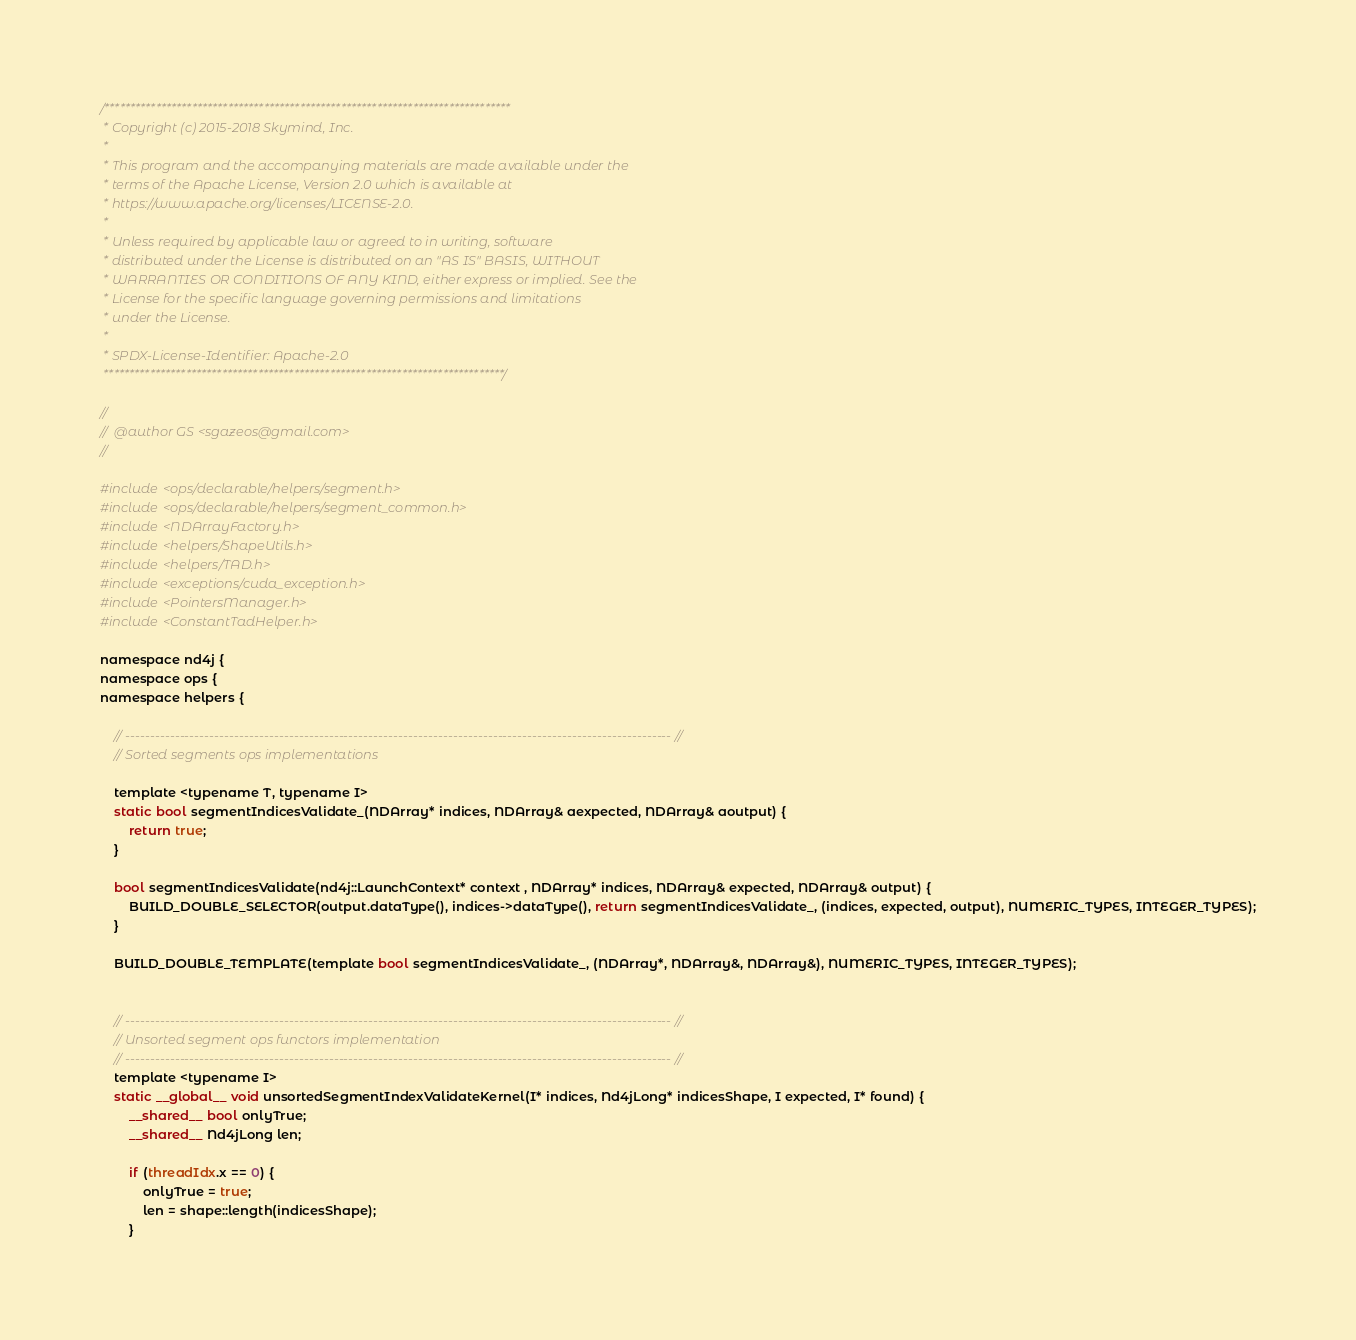Convert code to text. <code><loc_0><loc_0><loc_500><loc_500><_Cuda_>/*******************************************************************************
 * Copyright (c) 2015-2018 Skymind, Inc.
 *
 * This program and the accompanying materials are made available under the
 * terms of the Apache License, Version 2.0 which is available at
 * https://www.apache.org/licenses/LICENSE-2.0.
 *
 * Unless required by applicable law or agreed to in writing, software
 * distributed under the License is distributed on an "AS IS" BASIS, WITHOUT
 * WARRANTIES OR CONDITIONS OF ANY KIND, either express or implied. See the
 * License for the specific language governing permissions and limitations
 * under the License.
 *
 * SPDX-License-Identifier: Apache-2.0
 ******************************************************************************/

//
//  @author GS <sgazeos@gmail.com>
//

#include <ops/declarable/helpers/segment.h>
#include <ops/declarable/helpers/segment_common.h>
#include <NDArrayFactory.h>
#include <helpers/ShapeUtils.h>
#include <helpers/TAD.h>
#include <exceptions/cuda_exception.h>
#include <PointersManager.h>
#include <ConstantTadHelper.h>

namespace nd4j {
namespace ops {
namespace helpers {

    // -------------------------------------------------------------------------------------------------------------- //
    // Sorted segments ops implementations

    template <typename T, typename I>
    static bool segmentIndicesValidate_(NDArray* indices, NDArray& aexpected, NDArray& aoutput) {
        return true;
    }

    bool segmentIndicesValidate(nd4j::LaunchContext* context , NDArray* indices, NDArray& expected, NDArray& output) {
        BUILD_DOUBLE_SELECTOR(output.dataType(), indices->dataType(), return segmentIndicesValidate_, (indices, expected, output), NUMERIC_TYPES, INTEGER_TYPES);
    }

    BUILD_DOUBLE_TEMPLATE(template bool segmentIndicesValidate_, (NDArray*, NDArray&, NDArray&), NUMERIC_TYPES, INTEGER_TYPES);


    // -------------------------------------------------------------------------------------------------------------- //
    // Unsorted segment ops functors implementation
    // -------------------------------------------------------------------------------------------------------------- //
    template <typename I>
    static __global__ void unsortedSegmentIndexValidateKernel(I* indices, Nd4jLong* indicesShape, I expected, I* found) {
        __shared__ bool onlyTrue;
        __shared__ Nd4jLong len;

        if (threadIdx.x == 0) {
            onlyTrue = true;
            len = shape::length(indicesShape);
        }</code> 